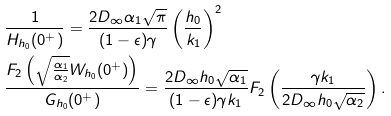Convert formula to latex. <formula><loc_0><loc_0><loc_500><loc_500>& \frac { 1 } { H _ { h _ { 0 } } ( 0 ^ { + } ) } = \frac { 2 D _ { \infty } \alpha _ { 1 } \sqrt { \pi } } { ( 1 - \epsilon ) \gamma } \left ( \frac { h _ { 0 } } { k _ { 1 } } \right ) ^ { 2 } \\ & \frac { F _ { 2 } \left ( \sqrt { \frac { \alpha _ { 1 } } { \alpha _ { 2 } } } W _ { h _ { 0 } } ( 0 ^ { + } ) \right ) } { G _ { h _ { 0 } } ( 0 ^ { + } ) } = \frac { 2 D _ { \infty } h _ { 0 } \sqrt { \alpha _ { 1 } } } { ( 1 - \epsilon ) \gamma k _ { 1 } } F _ { 2 } \left ( \frac { \gamma k _ { 1 } } { 2 D _ { \infty } h _ { 0 } \sqrt { \alpha _ { 2 } } } \right ) .</formula> 